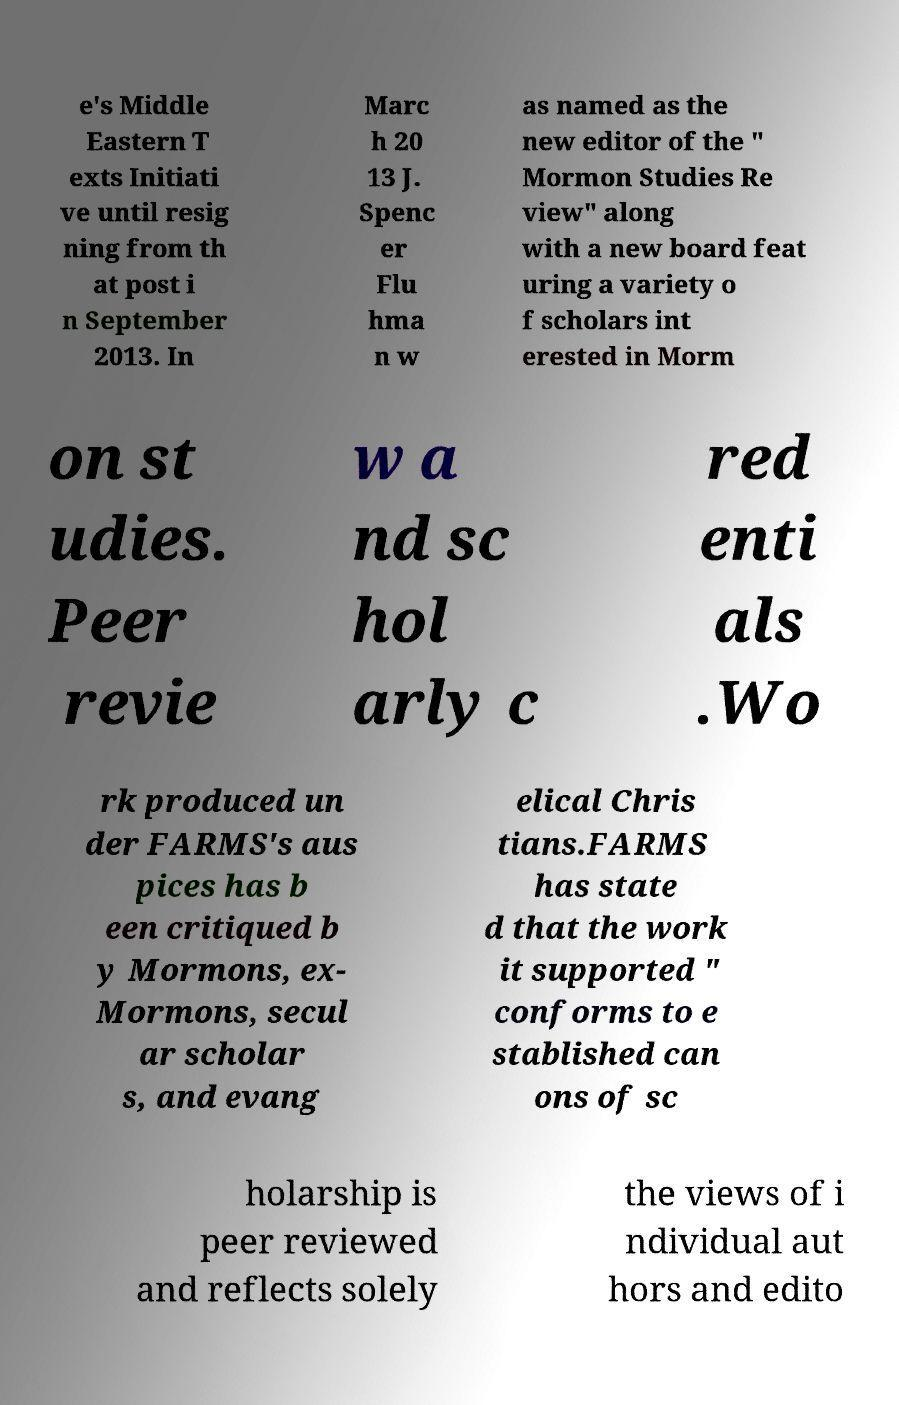Can you read and provide the text displayed in the image?This photo seems to have some interesting text. Can you extract and type it out for me? e's Middle Eastern T exts Initiati ve until resig ning from th at post i n September 2013. In Marc h 20 13 J. Spenc er Flu hma n w as named as the new editor of the " Mormon Studies Re view" along with a new board feat uring a variety o f scholars int erested in Morm on st udies. Peer revie w a nd sc hol arly c red enti als .Wo rk produced un der FARMS's aus pices has b een critiqued b y Mormons, ex- Mormons, secul ar scholar s, and evang elical Chris tians.FARMS has state d that the work it supported " conforms to e stablished can ons of sc holarship is peer reviewed and reflects solely the views of i ndividual aut hors and edito 